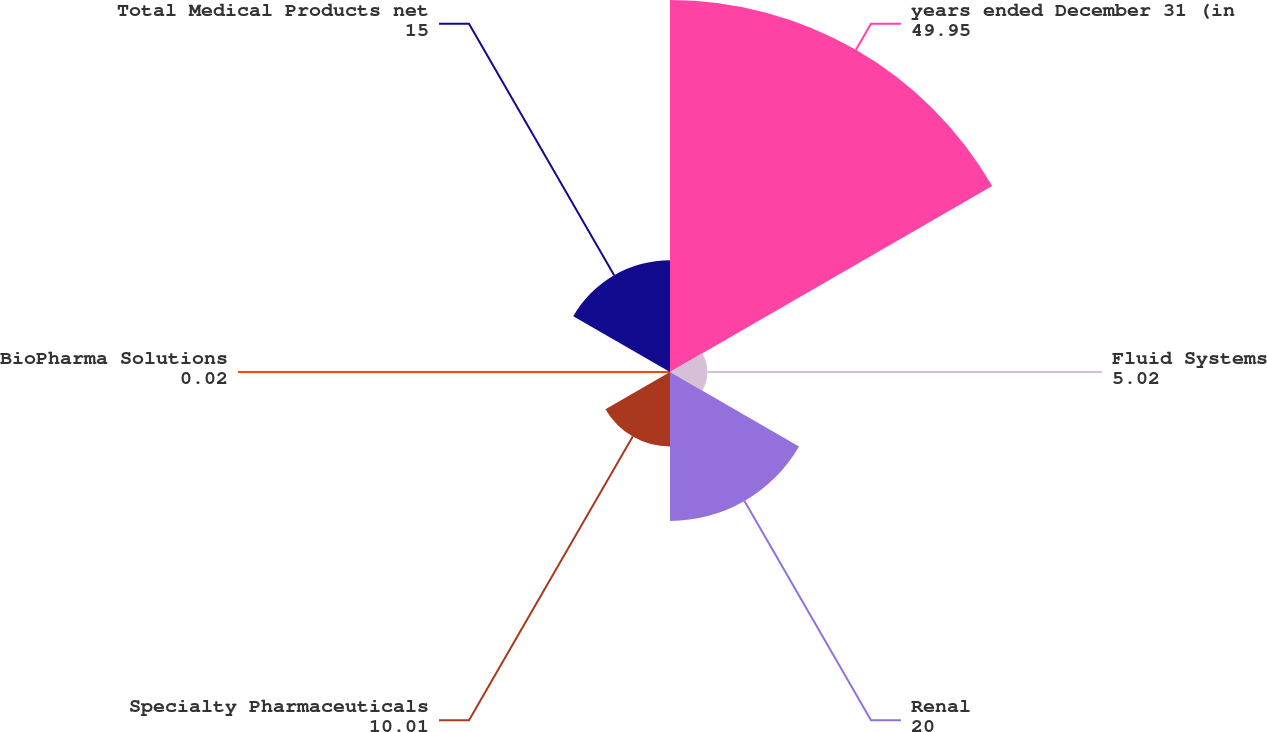Convert chart. <chart><loc_0><loc_0><loc_500><loc_500><pie_chart><fcel>years ended December 31 (in<fcel>Fluid Systems<fcel>Renal<fcel>Specialty Pharmaceuticals<fcel>BioPharma Solutions<fcel>Total Medical Products net<nl><fcel>49.95%<fcel>5.02%<fcel>20.0%<fcel>10.01%<fcel>0.02%<fcel>15.0%<nl></chart> 